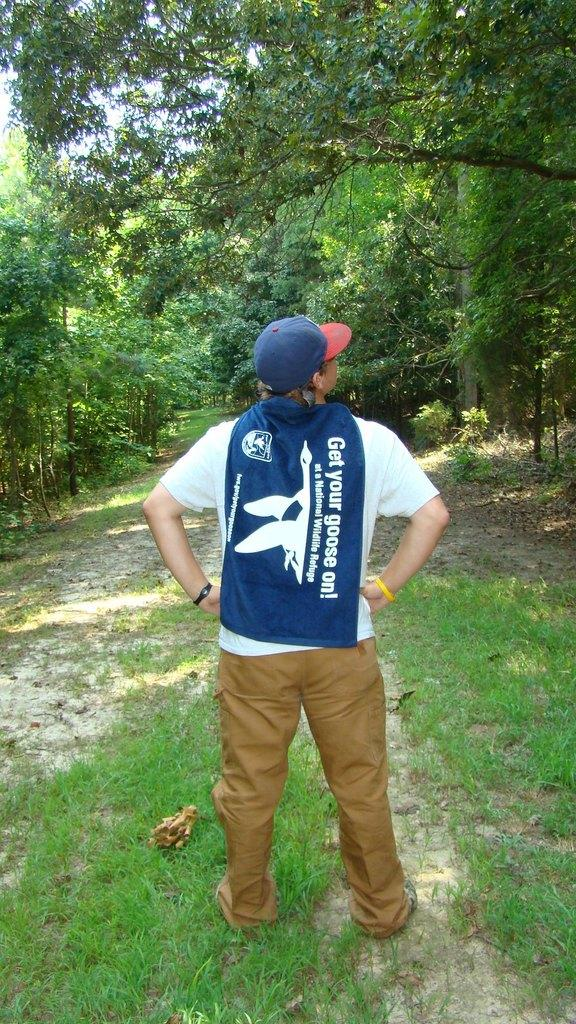<image>
Share a concise interpretation of the image provided. A man looks at the trees with a towel that says Get your goose on draped over his shoulders. 